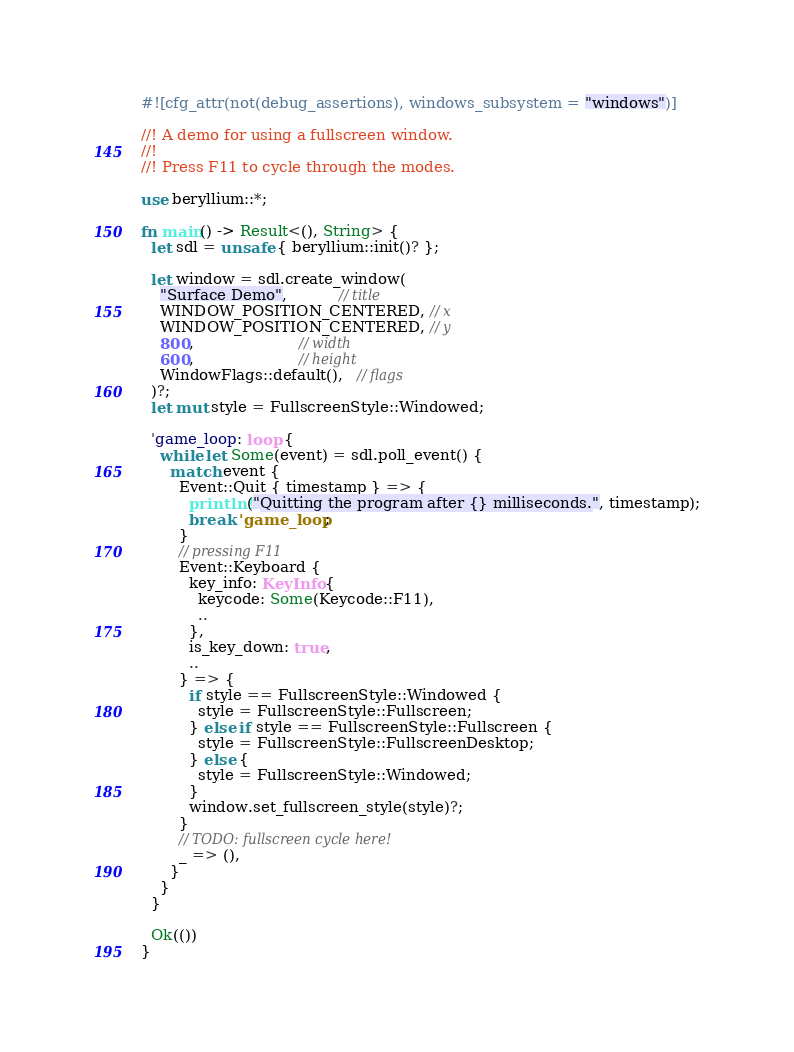Convert code to text. <code><loc_0><loc_0><loc_500><loc_500><_Rust_>#![cfg_attr(not(debug_assertions), windows_subsystem = "windows")]

//! A demo for using a fullscreen window.
//!
//! Press F11 to cycle through the modes.

use beryllium::*;

fn main() -> Result<(), String> {
  let sdl = unsafe { beryllium::init()? };

  let window = sdl.create_window(
    "Surface Demo",           // title
    WINDOW_POSITION_CENTERED, // x
    WINDOW_POSITION_CENTERED, // y
    800,                      // width
    600,                      // height
    WindowFlags::default(),   // flags
  )?;
  let mut style = FullscreenStyle::Windowed;

  'game_loop: loop {
    while let Some(event) = sdl.poll_event() {
      match event {
        Event::Quit { timestamp } => {
          println!("Quitting the program after {} milliseconds.", timestamp);
          break 'game_loop;
        }
        // pressing F11
        Event::Keyboard {
          key_info: KeyInfo {
            keycode: Some(Keycode::F11),
            ..
          },
          is_key_down: true,
          ..
        } => {
          if style == FullscreenStyle::Windowed {
            style = FullscreenStyle::Fullscreen;
          } else if style == FullscreenStyle::Fullscreen {
            style = FullscreenStyle::FullscreenDesktop;
          } else {
            style = FullscreenStyle::Windowed;
          }
          window.set_fullscreen_style(style)?;
        }
        // TODO: fullscreen cycle here!
        _ => (),
      }
    }
  }

  Ok(())
}
</code> 